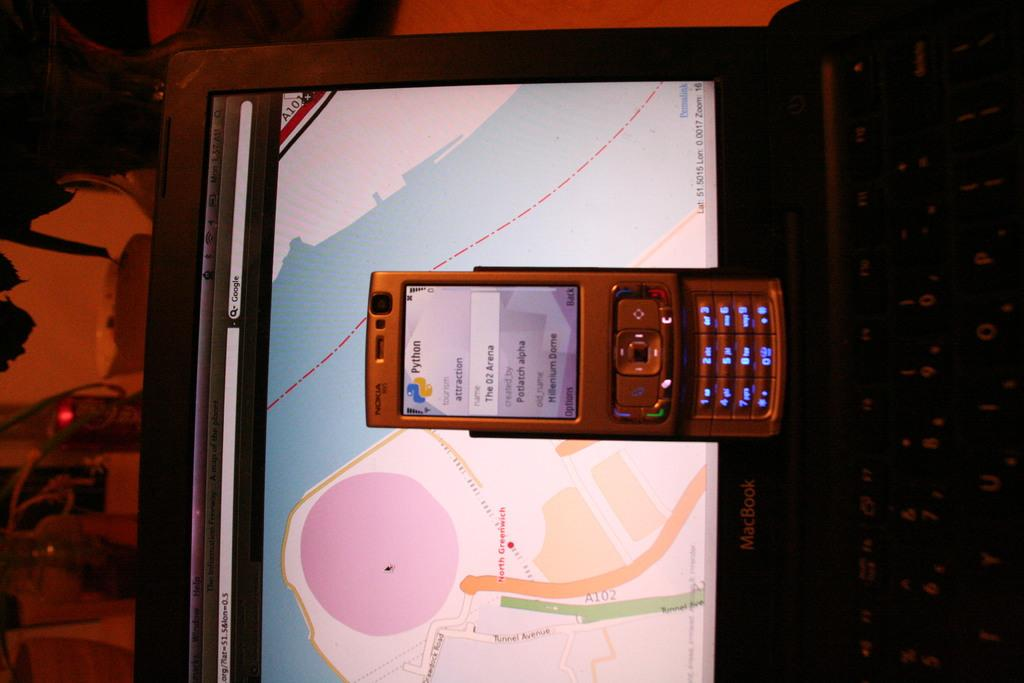<image>
Summarize the visual content of the image. A cell phone sitting on a laptop displaying a map or Greenwich 